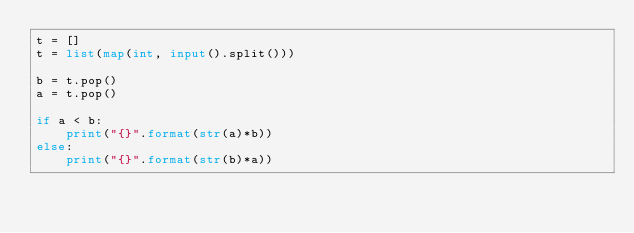Convert code to text. <code><loc_0><loc_0><loc_500><loc_500><_Python_>t = []
t = list(map(int, input().split()))

b = t.pop()
a = t.pop()

if a < b:
    print("{}".format(str(a)*b))
else:
    print("{}".format(str(b)*a))
</code> 